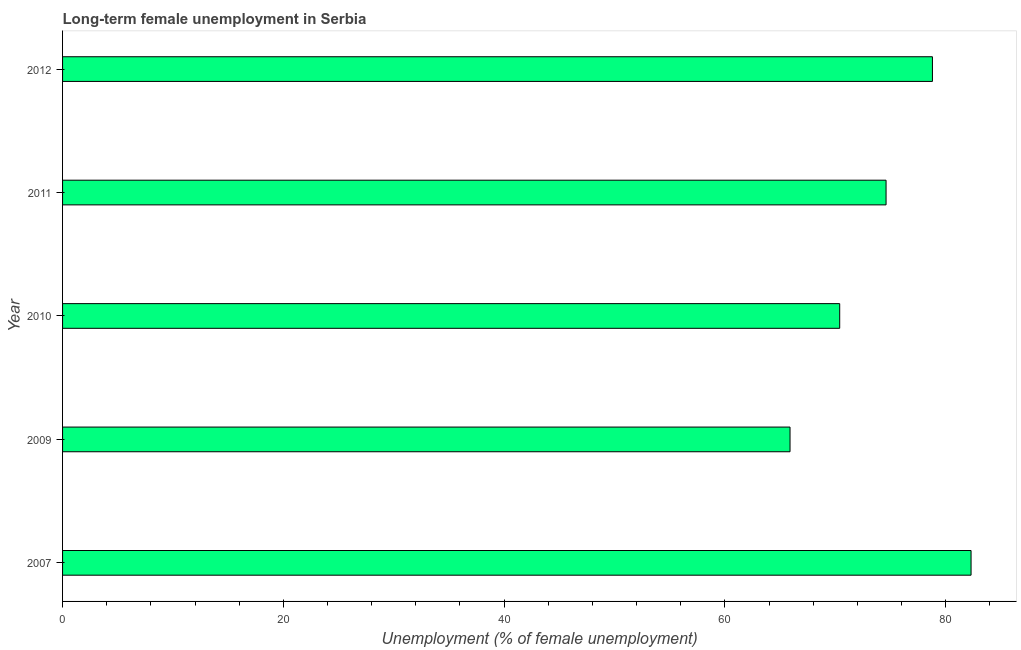Does the graph contain any zero values?
Your response must be concise. No. Does the graph contain grids?
Offer a very short reply. No. What is the title of the graph?
Provide a short and direct response. Long-term female unemployment in Serbia. What is the label or title of the X-axis?
Offer a terse response. Unemployment (% of female unemployment). What is the label or title of the Y-axis?
Make the answer very short. Year. What is the long-term female unemployment in 2007?
Ensure brevity in your answer.  82.3. Across all years, what is the maximum long-term female unemployment?
Ensure brevity in your answer.  82.3. Across all years, what is the minimum long-term female unemployment?
Provide a short and direct response. 65.9. In which year was the long-term female unemployment maximum?
Offer a terse response. 2007. What is the sum of the long-term female unemployment?
Provide a short and direct response. 372. What is the difference between the long-term female unemployment in 2007 and 2010?
Your answer should be compact. 11.9. What is the average long-term female unemployment per year?
Your answer should be very brief. 74.4. What is the median long-term female unemployment?
Your answer should be very brief. 74.6. Do a majority of the years between 2009 and 2012 (inclusive) have long-term female unemployment greater than 44 %?
Provide a short and direct response. Yes. What is the ratio of the long-term female unemployment in 2009 to that in 2012?
Provide a succinct answer. 0.84. What is the difference between the highest and the second highest long-term female unemployment?
Offer a very short reply. 3.5. What is the difference between the highest and the lowest long-term female unemployment?
Your answer should be very brief. 16.4. Are all the bars in the graph horizontal?
Your answer should be very brief. Yes. What is the difference between two consecutive major ticks on the X-axis?
Ensure brevity in your answer.  20. What is the Unemployment (% of female unemployment) in 2007?
Make the answer very short. 82.3. What is the Unemployment (% of female unemployment) in 2009?
Make the answer very short. 65.9. What is the Unemployment (% of female unemployment) in 2010?
Your response must be concise. 70.4. What is the Unemployment (% of female unemployment) in 2011?
Give a very brief answer. 74.6. What is the Unemployment (% of female unemployment) in 2012?
Keep it short and to the point. 78.8. What is the difference between the Unemployment (% of female unemployment) in 2007 and 2009?
Your answer should be compact. 16.4. What is the difference between the Unemployment (% of female unemployment) in 2007 and 2010?
Offer a terse response. 11.9. What is the difference between the Unemployment (% of female unemployment) in 2007 and 2011?
Offer a very short reply. 7.7. What is the difference between the Unemployment (% of female unemployment) in 2007 and 2012?
Your answer should be very brief. 3.5. What is the difference between the Unemployment (% of female unemployment) in 2010 and 2011?
Provide a short and direct response. -4.2. What is the difference between the Unemployment (% of female unemployment) in 2010 and 2012?
Make the answer very short. -8.4. What is the difference between the Unemployment (% of female unemployment) in 2011 and 2012?
Keep it short and to the point. -4.2. What is the ratio of the Unemployment (% of female unemployment) in 2007 to that in 2009?
Your answer should be compact. 1.25. What is the ratio of the Unemployment (% of female unemployment) in 2007 to that in 2010?
Offer a terse response. 1.17. What is the ratio of the Unemployment (% of female unemployment) in 2007 to that in 2011?
Ensure brevity in your answer.  1.1. What is the ratio of the Unemployment (% of female unemployment) in 2007 to that in 2012?
Provide a short and direct response. 1.04. What is the ratio of the Unemployment (% of female unemployment) in 2009 to that in 2010?
Provide a short and direct response. 0.94. What is the ratio of the Unemployment (% of female unemployment) in 2009 to that in 2011?
Your answer should be compact. 0.88. What is the ratio of the Unemployment (% of female unemployment) in 2009 to that in 2012?
Keep it short and to the point. 0.84. What is the ratio of the Unemployment (% of female unemployment) in 2010 to that in 2011?
Offer a terse response. 0.94. What is the ratio of the Unemployment (% of female unemployment) in 2010 to that in 2012?
Make the answer very short. 0.89. What is the ratio of the Unemployment (% of female unemployment) in 2011 to that in 2012?
Your response must be concise. 0.95. 